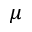Convert formula to latex. <formula><loc_0><loc_0><loc_500><loc_500>\mu</formula> 